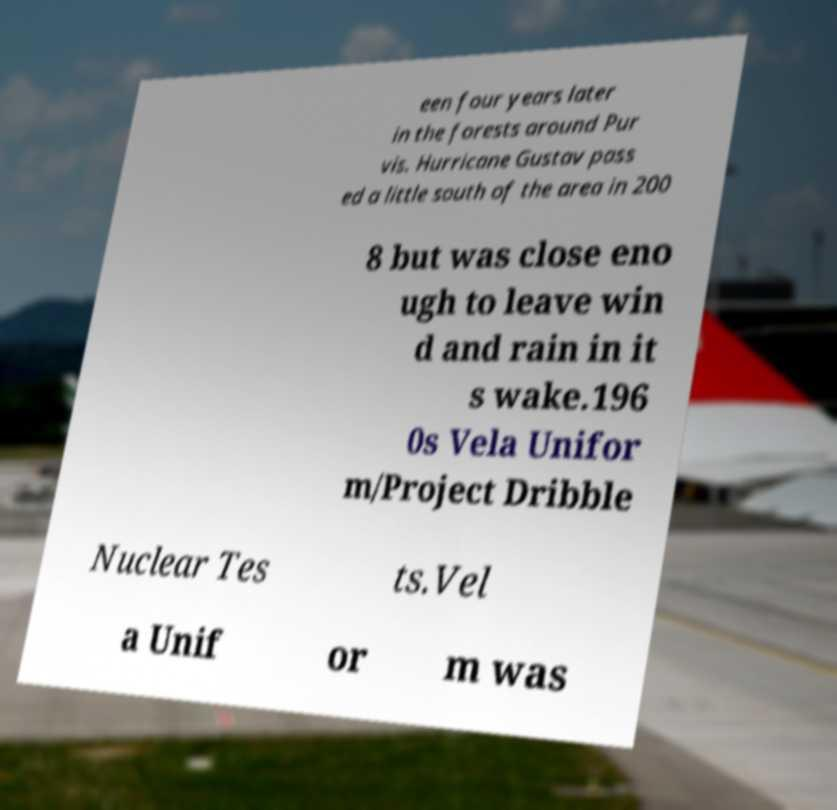I need the written content from this picture converted into text. Can you do that? een four years later in the forests around Pur vis. Hurricane Gustav pass ed a little south of the area in 200 8 but was close eno ugh to leave win d and rain in it s wake.196 0s Vela Unifor m/Project Dribble Nuclear Tes ts.Vel a Unif or m was 